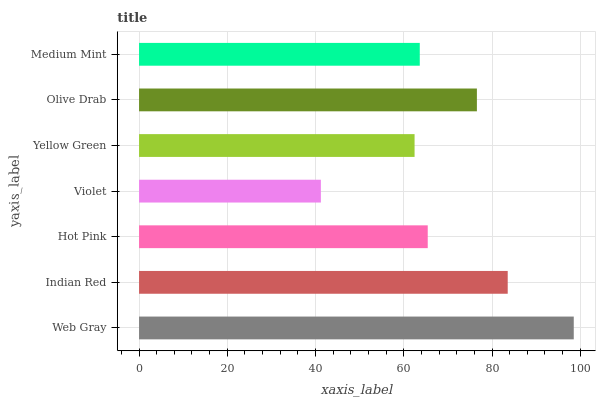Is Violet the minimum?
Answer yes or no. Yes. Is Web Gray the maximum?
Answer yes or no. Yes. Is Indian Red the minimum?
Answer yes or no. No. Is Indian Red the maximum?
Answer yes or no. No. Is Web Gray greater than Indian Red?
Answer yes or no. Yes. Is Indian Red less than Web Gray?
Answer yes or no. Yes. Is Indian Red greater than Web Gray?
Answer yes or no. No. Is Web Gray less than Indian Red?
Answer yes or no. No. Is Hot Pink the high median?
Answer yes or no. Yes. Is Hot Pink the low median?
Answer yes or no. Yes. Is Olive Drab the high median?
Answer yes or no. No. Is Yellow Green the low median?
Answer yes or no. No. 